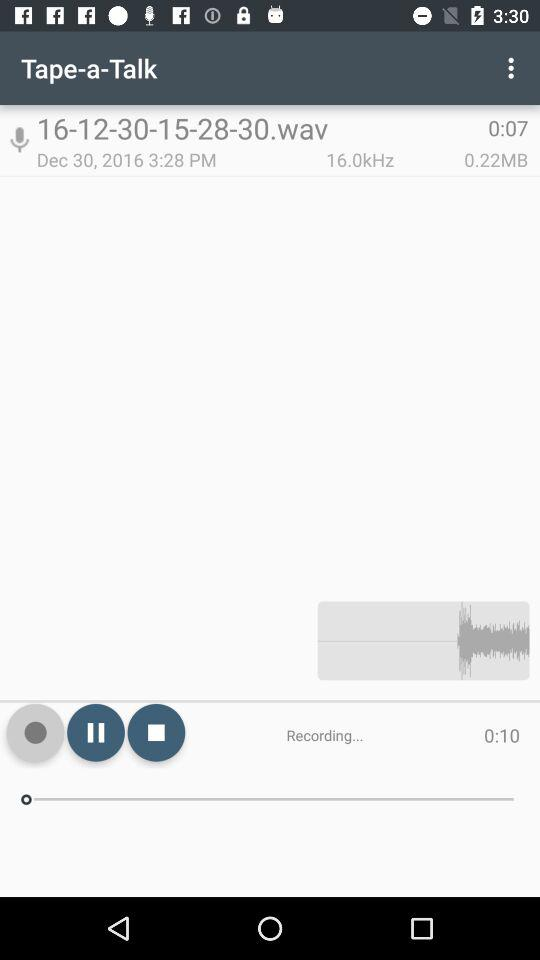What is the time of the recording? The time of the recording is 3:28 p.m. 